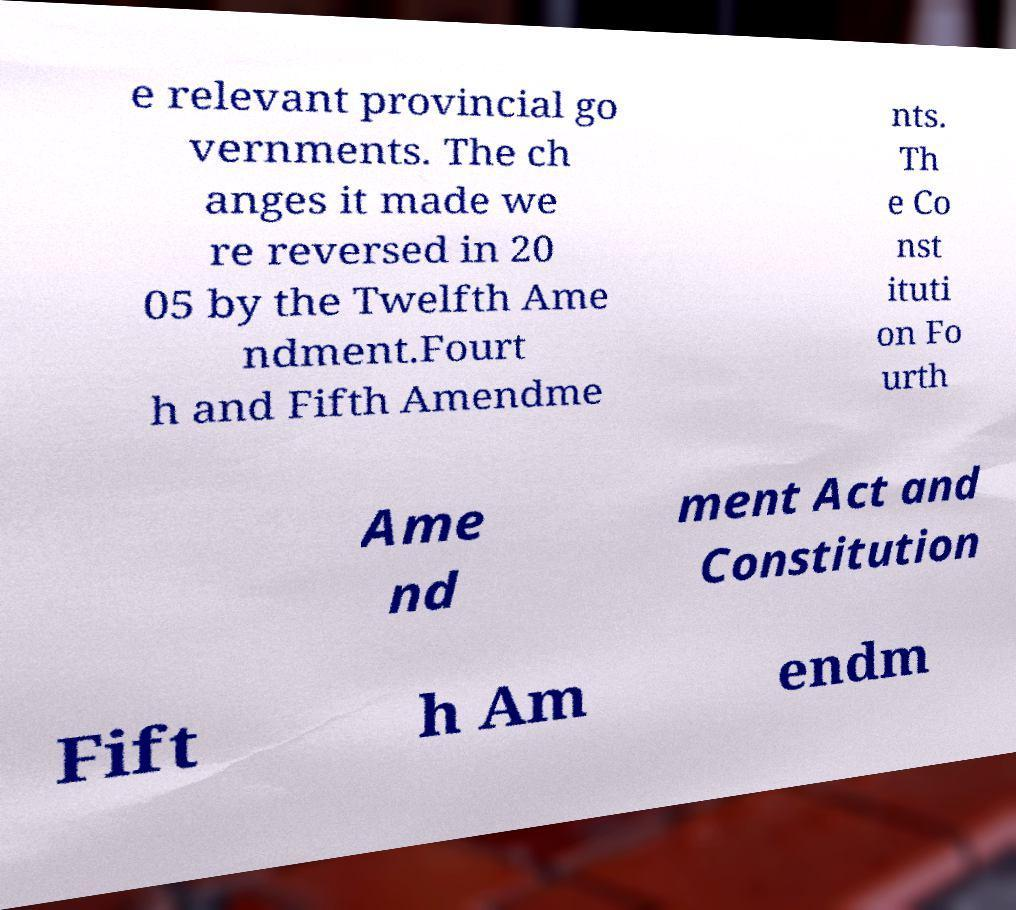What messages or text are displayed in this image? I need them in a readable, typed format. e relevant provincial go vernments. The ch anges it made we re reversed in 20 05 by the Twelfth Ame ndment.Fourt h and Fifth Amendme nts. Th e Co nst ituti on Fo urth Ame nd ment Act and Constitution Fift h Am endm 